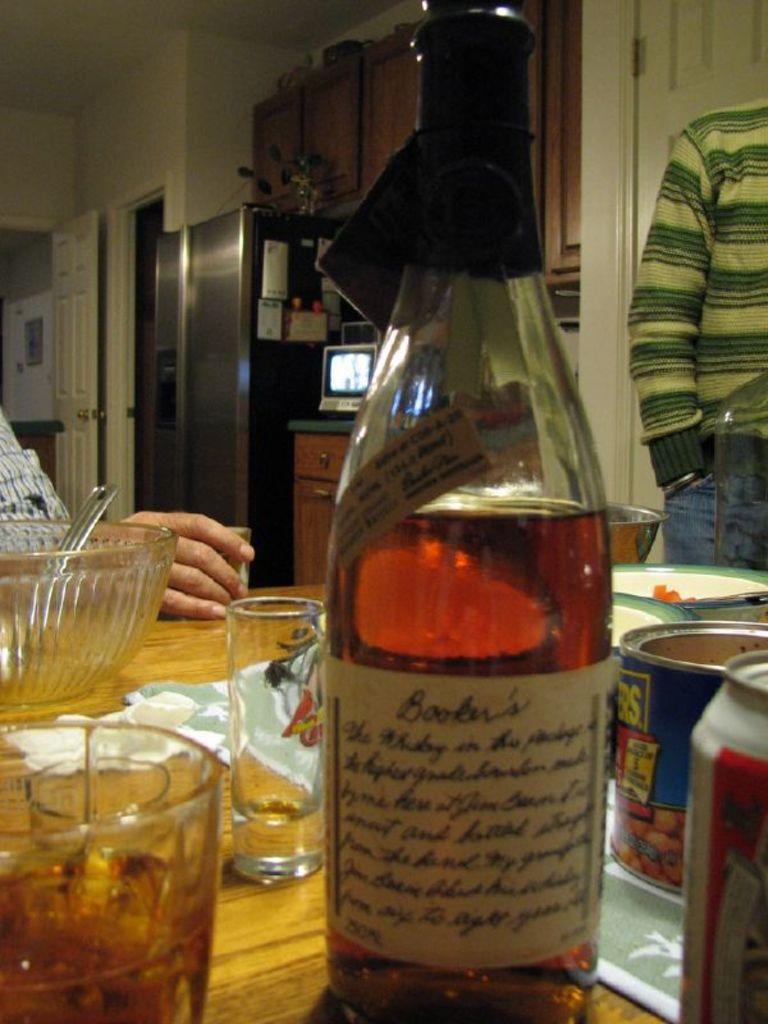Please provide a concise description of this image. In this image, There is a table which is in yellow color on that table there is a wine bottle, There is a glass, There is a bowl in white color, There are some cans on the table, In the left side there is a man sitting, In the right side there is a person standing, In the background there is a door in white color, There is a fridge in black color, There is a white color door in the left. 